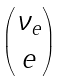Convert formula to latex. <formula><loc_0><loc_0><loc_500><loc_500>\begin{pmatrix} \nu _ { e } \\ e \end{pmatrix}</formula> 